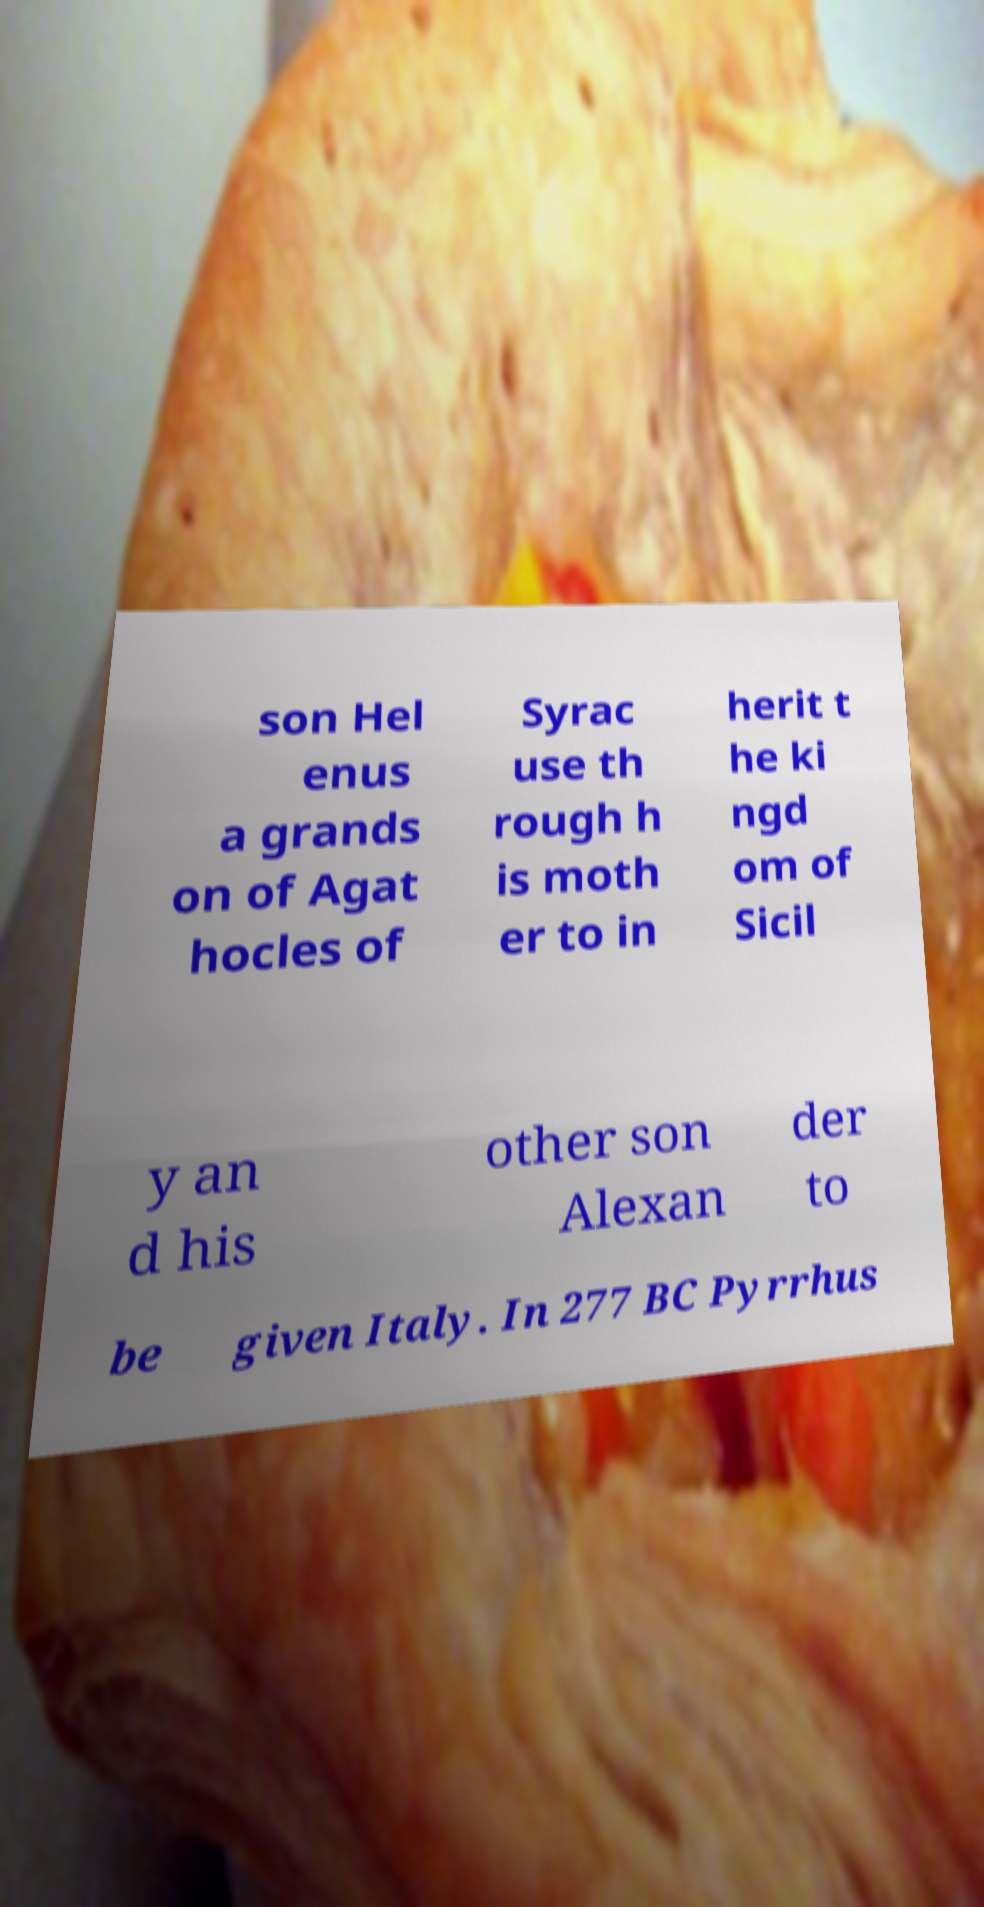Please read and relay the text visible in this image. What does it say? son Hel enus a grands on of Agat hocles of Syrac use th rough h is moth er to in herit t he ki ngd om of Sicil y an d his other son Alexan der to be given Italy. In 277 BC Pyrrhus 